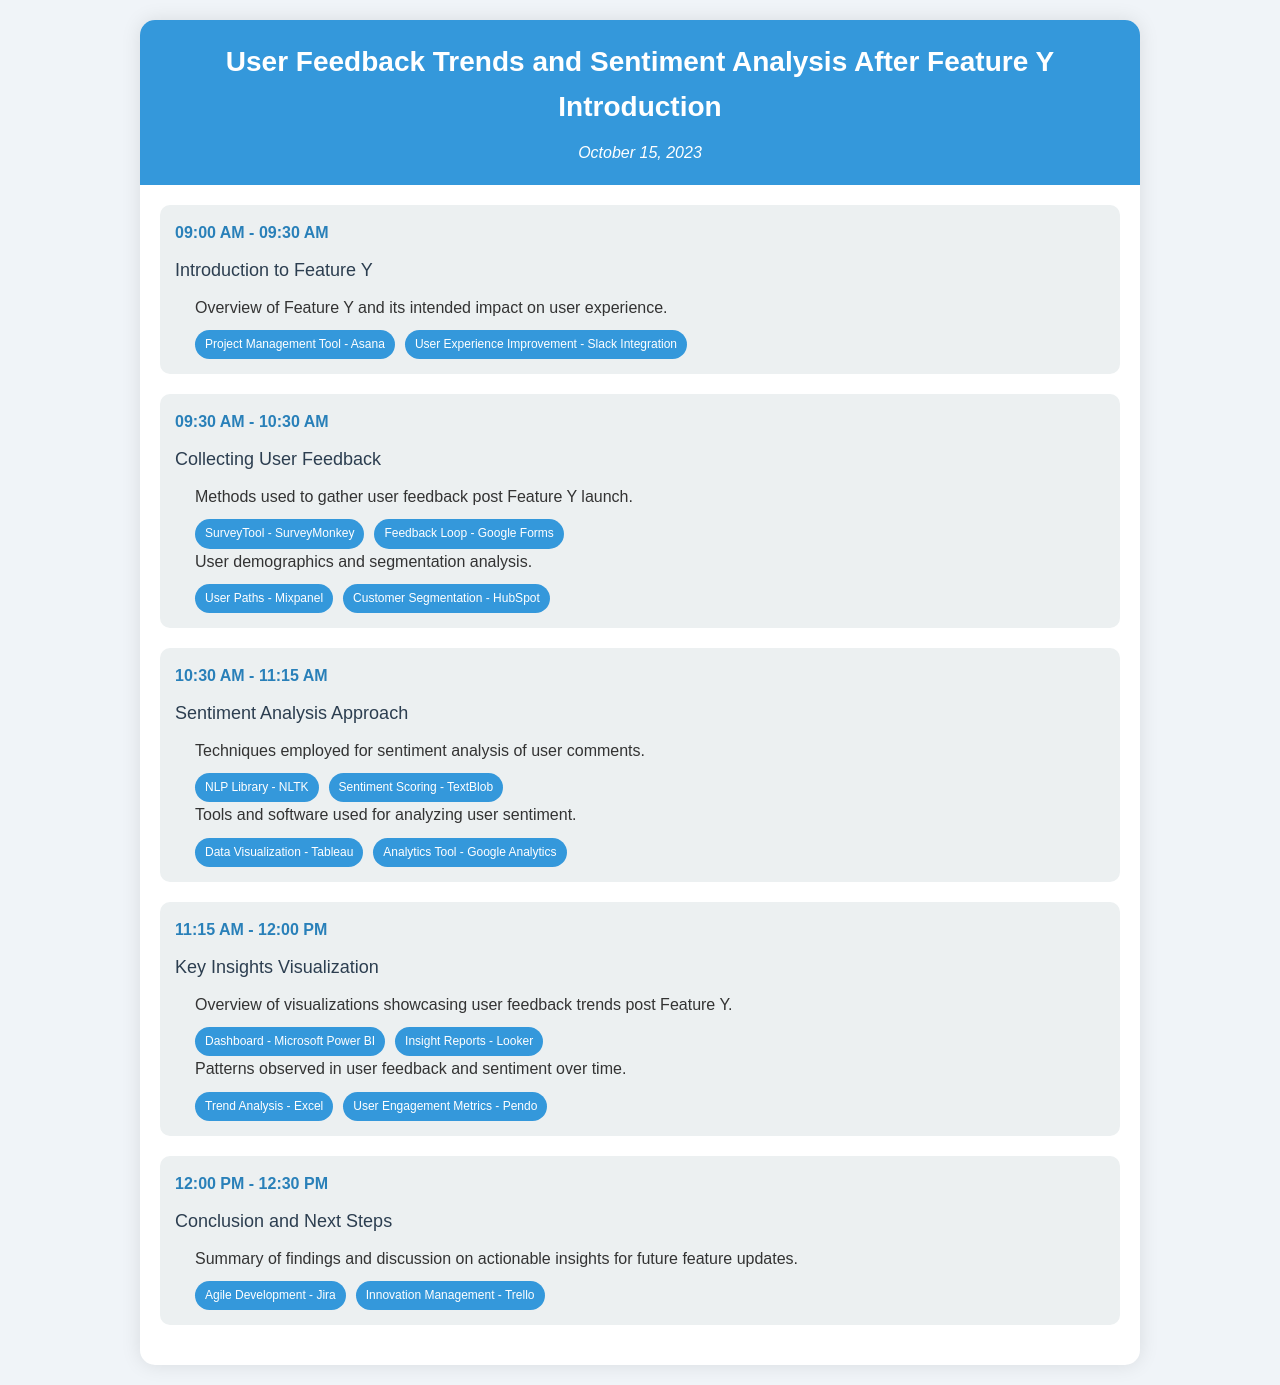What is the title of the document? The title of the document is stated in the header of the schedule.
Answer: User Feedback Trends and Sentiment Analysis After Feature Y Introduction What date is mentioned in the document? The date is shown just below the title in the header section.
Answer: October 15, 2023 How long is the Introduction to Feature Y session? The duration can be calculated from the start and end times listed in the schedule.
Answer: 30 minutes Which tool is used for conducting surveys? The tool is mentioned during the Collecting User Feedback session for gathering user opinions.
Answer: SurveyMonkey What two entities relate to user demographics analysis? These entities are associated with user segmentation analysis in the schedule.
Answer: User Paths - Mixpanel, Customer Segmentation - HubSpot Which session follows the Sentiment Analysis Approach session? The sessions are organized in chronological order in the document, and this must be determined from that order.
Answer: Key Insights Visualization How are user feedback trends displayed? Insights into user feedback trends are mentioned in the Key Insights Visualization section.
Answer: Visualizations What is the purpose of the Conclusion and Next Steps session? The purpose can be inferred from the description in the last session's content.
Answer: Summary of findings and discussion on actionable insights What does the NLP Library NLTK relate to? It is mentioned in the context of the Sentiment Analysis Approach session, showcasing its role.
Answer: Techniques for sentiment analysis 